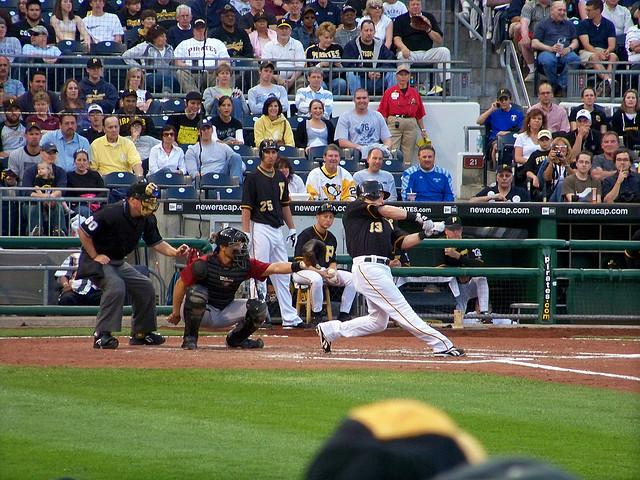Which former teammate of Chipper Jones is standing in the on-deck circle? catcher 